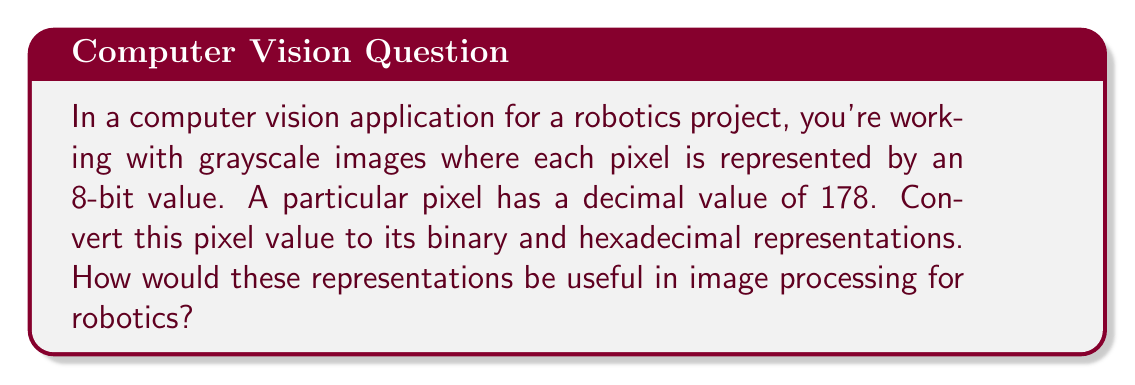Can you solve this math problem? Let's approach this step-by-step:

1) Converting decimal to binary:
   To convert 178 to binary, we divide by 2 repeatedly and keep track of the remainders:

   $178 \div 2 = 89$ remainder $0$
   $89 \div 2 = 44$  remainder $1$
   $44 \div 2 = 22$  remainder $0$
   $22 \div 2 = 11$  remainder $0$
   $11 \div 2 = 5$   remainder $1$
   $5 \div 2 = 2$    remainder $1$
   $2 \div 2 = 1$    remainder $0$
   $1 \div 2 = 0$    remainder $1$

   Reading the remainders from bottom to top, we get:
   $178_{10} = 10110010_2$

2) Converting decimal to hexadecimal:
   To convert to hexadecimal, we divide by 16 and keep track of the remainders:

   $178 \div 16 = 11$ remainder $2$
   $11 \div 16 = 0$   remainder $11$ (which is B in hexadecimal)

   Reading from bottom to top:
   $178_{10} = \text{B2}_{16}$

3) Usefulness in image processing for robotics:

   - Binary representation is useful for bitwise operations, which are often used in image processing algorithms like thresholding, edge detection, and morphological operations.
   
   - Hexadecimal representation is compact and often used in color coding. In RGB color spaces, each color channel is typically represented by two hexadecimal digits.
   
   - Both representations are important in data compression algorithms, which are crucial for efficient storage and transmission of image data in robotic systems with limited resources.
   
   - Understanding these representations helps in implementing low-level image processing operations that might be necessary for real-time computer vision tasks in robotics, such as object detection or visual servo control.
Answer: Binary representation: $10110010_2$
Hexadecimal representation: $\text{B2}_{16}$ 